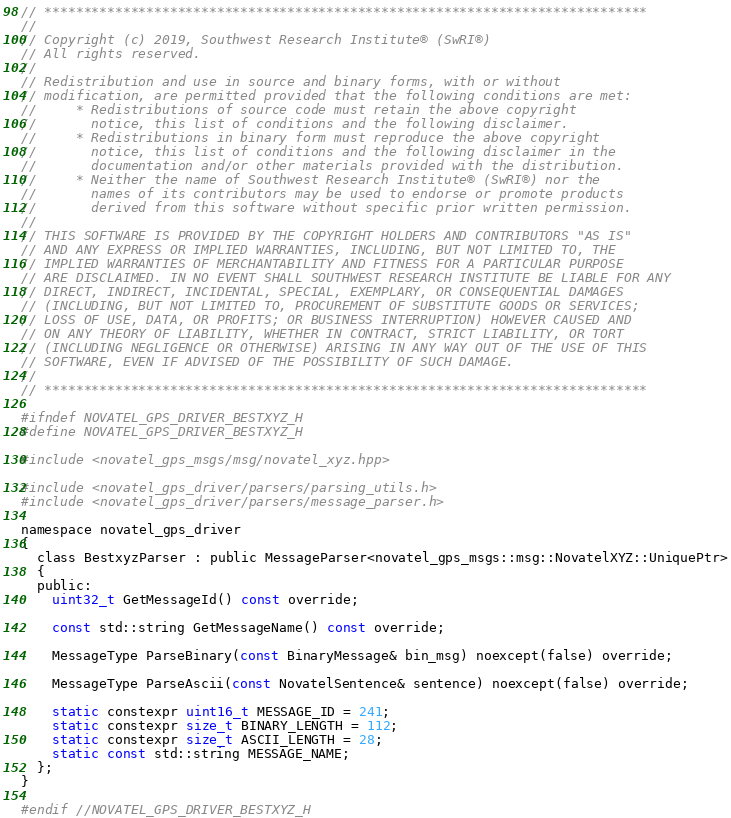Convert code to text. <code><loc_0><loc_0><loc_500><loc_500><_C_>// *****************************************************************************
//
// Copyright (c) 2019, Southwest Research Institute® (SwRI®)
// All rights reserved.
//
// Redistribution and use in source and binary forms, with or without
// modification, are permitted provided that the following conditions are met:
//     * Redistributions of source code must retain the above copyright
//       notice, this list of conditions and the following disclaimer.
//     * Redistributions in binary form must reproduce the above copyright
//       notice, this list of conditions and the following disclaimer in the
//       documentation and/or other materials provided with the distribution.
//     * Neither the name of Southwest Research Institute® (SwRI®) nor the
//       names of its contributors may be used to endorse or promote products
//       derived from this software without specific prior written permission.
//
// THIS SOFTWARE IS PROVIDED BY THE COPYRIGHT HOLDERS AND CONTRIBUTORS "AS IS"
// AND ANY EXPRESS OR IMPLIED WARRANTIES, INCLUDING, BUT NOT LIMITED TO, THE
// IMPLIED WARRANTIES OF MERCHANTABILITY AND FITNESS FOR A PARTICULAR PURPOSE
// ARE DISCLAIMED. IN NO EVENT SHALL SOUTHWEST RESEARCH INSTITUTE BE LIABLE FOR ANY
// DIRECT, INDIRECT, INCIDENTAL, SPECIAL, EXEMPLARY, OR CONSEQUENTIAL DAMAGES
// (INCLUDING, BUT NOT LIMITED TO, PROCUREMENT OF SUBSTITUTE GOODS OR SERVICES;
// LOSS OF USE, DATA, OR PROFITS; OR BUSINESS INTERRUPTION) HOWEVER CAUSED AND
// ON ANY THEORY OF LIABILITY, WHETHER IN CONTRACT, STRICT LIABILITY, OR TORT
// (INCLUDING NEGLIGENCE OR OTHERWISE) ARISING IN ANY WAY OUT OF THE USE OF THIS
// SOFTWARE, EVEN IF ADVISED OF THE POSSIBILITY OF SUCH DAMAGE.
//
// *****************************************************************************

#ifndef NOVATEL_GPS_DRIVER_BESTXYZ_H
#define NOVATEL_GPS_DRIVER_BESTXYZ_H

#include <novatel_gps_msgs/msg/novatel_xyz.hpp>

#include <novatel_gps_driver/parsers/parsing_utils.h>
#include <novatel_gps_driver/parsers/message_parser.h>

namespace novatel_gps_driver
{
  class BestxyzParser : public MessageParser<novatel_gps_msgs::msg::NovatelXYZ::UniquePtr>
  {
  public:
    uint32_t GetMessageId() const override;

    const std::string GetMessageName() const override;

    MessageType ParseBinary(const BinaryMessage& bin_msg) noexcept(false) override;

    MessageType ParseAscii(const NovatelSentence& sentence) noexcept(false) override;

    static constexpr uint16_t MESSAGE_ID = 241;
    static constexpr size_t BINARY_LENGTH = 112;
    static constexpr size_t ASCII_LENGTH = 28;
    static const std::string MESSAGE_NAME;
  };
}

#endif //NOVATEL_GPS_DRIVER_BESTXYZ_H
</code> 